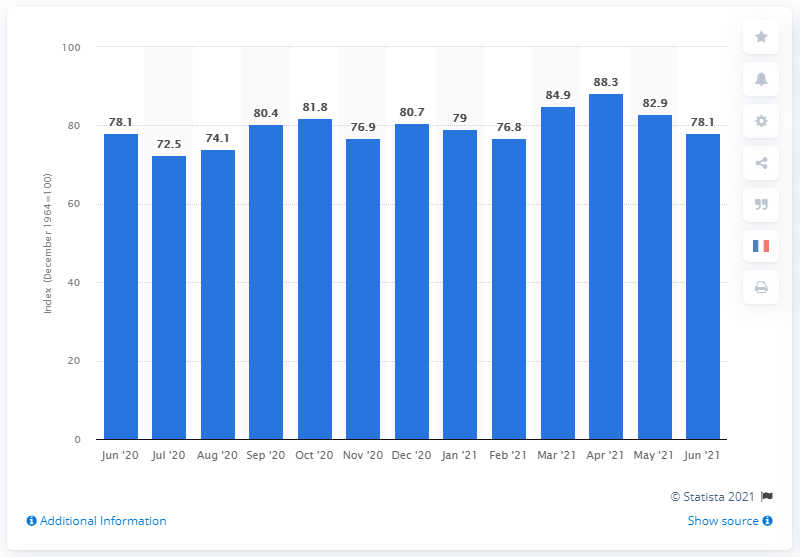Point out several critical features in this image. In June 2021, the Consumer Sentiment Index was 78.1, indicating a positive outlook among consumers. 